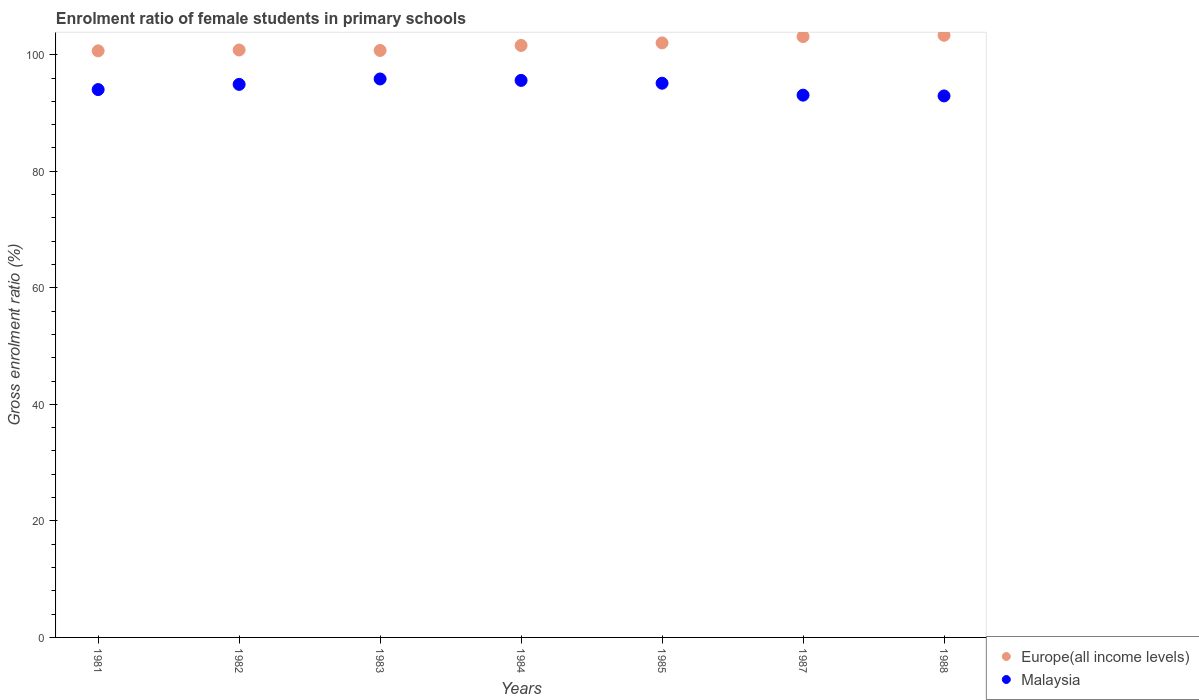Is the number of dotlines equal to the number of legend labels?
Make the answer very short. Yes. What is the enrolment ratio of female students in primary schools in Malaysia in 1982?
Provide a succinct answer. 94.91. Across all years, what is the maximum enrolment ratio of female students in primary schools in Europe(all income levels)?
Provide a short and direct response. 103.33. Across all years, what is the minimum enrolment ratio of female students in primary schools in Malaysia?
Your response must be concise. 92.93. In which year was the enrolment ratio of female students in primary schools in Malaysia maximum?
Your answer should be compact. 1983. What is the total enrolment ratio of female students in primary schools in Malaysia in the graph?
Make the answer very short. 661.44. What is the difference between the enrolment ratio of female students in primary schools in Malaysia in 1985 and that in 1988?
Offer a very short reply. 2.18. What is the difference between the enrolment ratio of female students in primary schools in Europe(all income levels) in 1988 and the enrolment ratio of female students in primary schools in Malaysia in 1987?
Keep it short and to the point. 10.27. What is the average enrolment ratio of female students in primary schools in Malaysia per year?
Your answer should be compact. 94.49. In the year 1988, what is the difference between the enrolment ratio of female students in primary schools in Europe(all income levels) and enrolment ratio of female students in primary schools in Malaysia?
Offer a terse response. 10.41. What is the ratio of the enrolment ratio of female students in primary schools in Malaysia in 1983 to that in 1988?
Your answer should be very brief. 1.03. What is the difference between the highest and the second highest enrolment ratio of female students in primary schools in Malaysia?
Your answer should be compact. 0.25. What is the difference between the highest and the lowest enrolment ratio of female students in primary schools in Malaysia?
Give a very brief answer. 2.91. In how many years, is the enrolment ratio of female students in primary schools in Malaysia greater than the average enrolment ratio of female students in primary schools in Malaysia taken over all years?
Offer a terse response. 4. Is the sum of the enrolment ratio of female students in primary schools in Malaysia in 1985 and 1988 greater than the maximum enrolment ratio of female students in primary schools in Europe(all income levels) across all years?
Your answer should be very brief. Yes. Is the enrolment ratio of female students in primary schools in Malaysia strictly greater than the enrolment ratio of female students in primary schools in Europe(all income levels) over the years?
Your answer should be very brief. No. What is the title of the graph?
Provide a succinct answer. Enrolment ratio of female students in primary schools. Does "Belgium" appear as one of the legend labels in the graph?
Provide a short and direct response. No. What is the label or title of the X-axis?
Provide a succinct answer. Years. What is the label or title of the Y-axis?
Provide a succinct answer. Gross enrolment ratio (%). What is the Gross enrolment ratio (%) of Europe(all income levels) in 1981?
Your response must be concise. 100.66. What is the Gross enrolment ratio (%) in Malaysia in 1981?
Your answer should be very brief. 94.01. What is the Gross enrolment ratio (%) in Europe(all income levels) in 1982?
Ensure brevity in your answer.  100.81. What is the Gross enrolment ratio (%) in Malaysia in 1982?
Your answer should be compact. 94.91. What is the Gross enrolment ratio (%) in Europe(all income levels) in 1983?
Provide a short and direct response. 100.73. What is the Gross enrolment ratio (%) of Malaysia in 1983?
Provide a short and direct response. 95.84. What is the Gross enrolment ratio (%) in Europe(all income levels) in 1984?
Ensure brevity in your answer.  101.59. What is the Gross enrolment ratio (%) in Malaysia in 1984?
Give a very brief answer. 95.59. What is the Gross enrolment ratio (%) in Europe(all income levels) in 1985?
Your answer should be very brief. 102.03. What is the Gross enrolment ratio (%) in Malaysia in 1985?
Provide a succinct answer. 95.1. What is the Gross enrolment ratio (%) in Europe(all income levels) in 1987?
Your answer should be very brief. 103.11. What is the Gross enrolment ratio (%) of Malaysia in 1987?
Keep it short and to the point. 93.06. What is the Gross enrolment ratio (%) in Europe(all income levels) in 1988?
Give a very brief answer. 103.33. What is the Gross enrolment ratio (%) of Malaysia in 1988?
Make the answer very short. 92.93. Across all years, what is the maximum Gross enrolment ratio (%) of Europe(all income levels)?
Your response must be concise. 103.33. Across all years, what is the maximum Gross enrolment ratio (%) of Malaysia?
Offer a very short reply. 95.84. Across all years, what is the minimum Gross enrolment ratio (%) of Europe(all income levels)?
Ensure brevity in your answer.  100.66. Across all years, what is the minimum Gross enrolment ratio (%) in Malaysia?
Your answer should be compact. 92.93. What is the total Gross enrolment ratio (%) of Europe(all income levels) in the graph?
Your response must be concise. 712.26. What is the total Gross enrolment ratio (%) of Malaysia in the graph?
Your response must be concise. 661.44. What is the difference between the Gross enrolment ratio (%) in Europe(all income levels) in 1981 and that in 1982?
Offer a terse response. -0.15. What is the difference between the Gross enrolment ratio (%) of Malaysia in 1981 and that in 1982?
Your answer should be very brief. -0.89. What is the difference between the Gross enrolment ratio (%) of Europe(all income levels) in 1981 and that in 1983?
Offer a terse response. -0.07. What is the difference between the Gross enrolment ratio (%) of Malaysia in 1981 and that in 1983?
Make the answer very short. -1.82. What is the difference between the Gross enrolment ratio (%) of Europe(all income levels) in 1981 and that in 1984?
Ensure brevity in your answer.  -0.93. What is the difference between the Gross enrolment ratio (%) in Malaysia in 1981 and that in 1984?
Provide a succinct answer. -1.58. What is the difference between the Gross enrolment ratio (%) in Europe(all income levels) in 1981 and that in 1985?
Your answer should be compact. -1.37. What is the difference between the Gross enrolment ratio (%) of Malaysia in 1981 and that in 1985?
Your answer should be very brief. -1.09. What is the difference between the Gross enrolment ratio (%) of Europe(all income levels) in 1981 and that in 1987?
Your response must be concise. -2.45. What is the difference between the Gross enrolment ratio (%) of Malaysia in 1981 and that in 1987?
Keep it short and to the point. 0.96. What is the difference between the Gross enrolment ratio (%) in Europe(all income levels) in 1981 and that in 1988?
Offer a very short reply. -2.67. What is the difference between the Gross enrolment ratio (%) of Malaysia in 1981 and that in 1988?
Keep it short and to the point. 1.09. What is the difference between the Gross enrolment ratio (%) in Europe(all income levels) in 1982 and that in 1983?
Give a very brief answer. 0.08. What is the difference between the Gross enrolment ratio (%) in Malaysia in 1982 and that in 1983?
Offer a very short reply. -0.93. What is the difference between the Gross enrolment ratio (%) in Europe(all income levels) in 1982 and that in 1984?
Your answer should be compact. -0.78. What is the difference between the Gross enrolment ratio (%) in Malaysia in 1982 and that in 1984?
Your response must be concise. -0.68. What is the difference between the Gross enrolment ratio (%) in Europe(all income levels) in 1982 and that in 1985?
Offer a terse response. -1.22. What is the difference between the Gross enrolment ratio (%) in Malaysia in 1982 and that in 1985?
Make the answer very short. -0.2. What is the difference between the Gross enrolment ratio (%) of Europe(all income levels) in 1982 and that in 1987?
Your answer should be very brief. -2.31. What is the difference between the Gross enrolment ratio (%) in Malaysia in 1982 and that in 1987?
Provide a succinct answer. 1.85. What is the difference between the Gross enrolment ratio (%) in Europe(all income levels) in 1982 and that in 1988?
Provide a succinct answer. -2.53. What is the difference between the Gross enrolment ratio (%) in Malaysia in 1982 and that in 1988?
Provide a short and direct response. 1.98. What is the difference between the Gross enrolment ratio (%) in Europe(all income levels) in 1983 and that in 1984?
Give a very brief answer. -0.86. What is the difference between the Gross enrolment ratio (%) of Malaysia in 1983 and that in 1984?
Give a very brief answer. 0.25. What is the difference between the Gross enrolment ratio (%) in Europe(all income levels) in 1983 and that in 1985?
Your answer should be compact. -1.3. What is the difference between the Gross enrolment ratio (%) in Malaysia in 1983 and that in 1985?
Keep it short and to the point. 0.73. What is the difference between the Gross enrolment ratio (%) in Europe(all income levels) in 1983 and that in 1987?
Offer a very short reply. -2.38. What is the difference between the Gross enrolment ratio (%) of Malaysia in 1983 and that in 1987?
Your answer should be compact. 2.78. What is the difference between the Gross enrolment ratio (%) of Europe(all income levels) in 1983 and that in 1988?
Ensure brevity in your answer.  -2.6. What is the difference between the Gross enrolment ratio (%) of Malaysia in 1983 and that in 1988?
Provide a short and direct response. 2.91. What is the difference between the Gross enrolment ratio (%) in Europe(all income levels) in 1984 and that in 1985?
Make the answer very short. -0.44. What is the difference between the Gross enrolment ratio (%) in Malaysia in 1984 and that in 1985?
Provide a succinct answer. 0.49. What is the difference between the Gross enrolment ratio (%) of Europe(all income levels) in 1984 and that in 1987?
Your answer should be very brief. -1.52. What is the difference between the Gross enrolment ratio (%) of Malaysia in 1984 and that in 1987?
Provide a short and direct response. 2.53. What is the difference between the Gross enrolment ratio (%) in Europe(all income levels) in 1984 and that in 1988?
Your response must be concise. -1.74. What is the difference between the Gross enrolment ratio (%) in Malaysia in 1984 and that in 1988?
Your response must be concise. 2.66. What is the difference between the Gross enrolment ratio (%) in Europe(all income levels) in 1985 and that in 1987?
Offer a terse response. -1.09. What is the difference between the Gross enrolment ratio (%) of Malaysia in 1985 and that in 1987?
Make the answer very short. 2.05. What is the difference between the Gross enrolment ratio (%) of Europe(all income levels) in 1985 and that in 1988?
Your response must be concise. -1.31. What is the difference between the Gross enrolment ratio (%) of Malaysia in 1985 and that in 1988?
Make the answer very short. 2.18. What is the difference between the Gross enrolment ratio (%) in Europe(all income levels) in 1987 and that in 1988?
Provide a succinct answer. -0.22. What is the difference between the Gross enrolment ratio (%) of Malaysia in 1987 and that in 1988?
Give a very brief answer. 0.13. What is the difference between the Gross enrolment ratio (%) of Europe(all income levels) in 1981 and the Gross enrolment ratio (%) of Malaysia in 1982?
Ensure brevity in your answer.  5.75. What is the difference between the Gross enrolment ratio (%) in Europe(all income levels) in 1981 and the Gross enrolment ratio (%) in Malaysia in 1983?
Provide a short and direct response. 4.82. What is the difference between the Gross enrolment ratio (%) of Europe(all income levels) in 1981 and the Gross enrolment ratio (%) of Malaysia in 1984?
Offer a very short reply. 5.07. What is the difference between the Gross enrolment ratio (%) of Europe(all income levels) in 1981 and the Gross enrolment ratio (%) of Malaysia in 1985?
Ensure brevity in your answer.  5.56. What is the difference between the Gross enrolment ratio (%) in Europe(all income levels) in 1981 and the Gross enrolment ratio (%) in Malaysia in 1987?
Offer a very short reply. 7.6. What is the difference between the Gross enrolment ratio (%) in Europe(all income levels) in 1981 and the Gross enrolment ratio (%) in Malaysia in 1988?
Ensure brevity in your answer.  7.73. What is the difference between the Gross enrolment ratio (%) of Europe(all income levels) in 1982 and the Gross enrolment ratio (%) of Malaysia in 1983?
Provide a succinct answer. 4.97. What is the difference between the Gross enrolment ratio (%) of Europe(all income levels) in 1982 and the Gross enrolment ratio (%) of Malaysia in 1984?
Give a very brief answer. 5.22. What is the difference between the Gross enrolment ratio (%) of Europe(all income levels) in 1982 and the Gross enrolment ratio (%) of Malaysia in 1985?
Offer a very short reply. 5.7. What is the difference between the Gross enrolment ratio (%) of Europe(all income levels) in 1982 and the Gross enrolment ratio (%) of Malaysia in 1987?
Your answer should be compact. 7.75. What is the difference between the Gross enrolment ratio (%) of Europe(all income levels) in 1982 and the Gross enrolment ratio (%) of Malaysia in 1988?
Give a very brief answer. 7.88. What is the difference between the Gross enrolment ratio (%) of Europe(all income levels) in 1983 and the Gross enrolment ratio (%) of Malaysia in 1984?
Keep it short and to the point. 5.14. What is the difference between the Gross enrolment ratio (%) in Europe(all income levels) in 1983 and the Gross enrolment ratio (%) in Malaysia in 1985?
Keep it short and to the point. 5.63. What is the difference between the Gross enrolment ratio (%) of Europe(all income levels) in 1983 and the Gross enrolment ratio (%) of Malaysia in 1987?
Give a very brief answer. 7.67. What is the difference between the Gross enrolment ratio (%) of Europe(all income levels) in 1983 and the Gross enrolment ratio (%) of Malaysia in 1988?
Offer a very short reply. 7.8. What is the difference between the Gross enrolment ratio (%) of Europe(all income levels) in 1984 and the Gross enrolment ratio (%) of Malaysia in 1985?
Your answer should be compact. 6.48. What is the difference between the Gross enrolment ratio (%) of Europe(all income levels) in 1984 and the Gross enrolment ratio (%) of Malaysia in 1987?
Provide a succinct answer. 8.53. What is the difference between the Gross enrolment ratio (%) of Europe(all income levels) in 1984 and the Gross enrolment ratio (%) of Malaysia in 1988?
Offer a terse response. 8.66. What is the difference between the Gross enrolment ratio (%) of Europe(all income levels) in 1985 and the Gross enrolment ratio (%) of Malaysia in 1987?
Make the answer very short. 8.97. What is the difference between the Gross enrolment ratio (%) of Europe(all income levels) in 1985 and the Gross enrolment ratio (%) of Malaysia in 1988?
Make the answer very short. 9.1. What is the difference between the Gross enrolment ratio (%) in Europe(all income levels) in 1987 and the Gross enrolment ratio (%) in Malaysia in 1988?
Your response must be concise. 10.19. What is the average Gross enrolment ratio (%) in Europe(all income levels) per year?
Provide a succinct answer. 101.75. What is the average Gross enrolment ratio (%) in Malaysia per year?
Make the answer very short. 94.49. In the year 1981, what is the difference between the Gross enrolment ratio (%) in Europe(all income levels) and Gross enrolment ratio (%) in Malaysia?
Your answer should be compact. 6.65. In the year 1982, what is the difference between the Gross enrolment ratio (%) in Europe(all income levels) and Gross enrolment ratio (%) in Malaysia?
Offer a very short reply. 5.9. In the year 1983, what is the difference between the Gross enrolment ratio (%) of Europe(all income levels) and Gross enrolment ratio (%) of Malaysia?
Your response must be concise. 4.89. In the year 1984, what is the difference between the Gross enrolment ratio (%) of Europe(all income levels) and Gross enrolment ratio (%) of Malaysia?
Make the answer very short. 6. In the year 1985, what is the difference between the Gross enrolment ratio (%) in Europe(all income levels) and Gross enrolment ratio (%) in Malaysia?
Make the answer very short. 6.92. In the year 1987, what is the difference between the Gross enrolment ratio (%) of Europe(all income levels) and Gross enrolment ratio (%) of Malaysia?
Provide a short and direct response. 10.05. In the year 1988, what is the difference between the Gross enrolment ratio (%) in Europe(all income levels) and Gross enrolment ratio (%) in Malaysia?
Make the answer very short. 10.41. What is the ratio of the Gross enrolment ratio (%) of Malaysia in 1981 to that in 1982?
Offer a terse response. 0.99. What is the ratio of the Gross enrolment ratio (%) in Europe(all income levels) in 1981 to that in 1983?
Your response must be concise. 1. What is the ratio of the Gross enrolment ratio (%) in Europe(all income levels) in 1981 to that in 1984?
Offer a terse response. 0.99. What is the ratio of the Gross enrolment ratio (%) of Malaysia in 1981 to that in 1984?
Offer a terse response. 0.98. What is the ratio of the Gross enrolment ratio (%) of Europe(all income levels) in 1981 to that in 1985?
Provide a succinct answer. 0.99. What is the ratio of the Gross enrolment ratio (%) of Europe(all income levels) in 1981 to that in 1987?
Make the answer very short. 0.98. What is the ratio of the Gross enrolment ratio (%) of Malaysia in 1981 to that in 1987?
Your response must be concise. 1.01. What is the ratio of the Gross enrolment ratio (%) of Europe(all income levels) in 1981 to that in 1988?
Give a very brief answer. 0.97. What is the ratio of the Gross enrolment ratio (%) in Malaysia in 1981 to that in 1988?
Provide a succinct answer. 1.01. What is the ratio of the Gross enrolment ratio (%) of Malaysia in 1982 to that in 1983?
Your response must be concise. 0.99. What is the ratio of the Gross enrolment ratio (%) in Europe(all income levels) in 1982 to that in 1984?
Provide a short and direct response. 0.99. What is the ratio of the Gross enrolment ratio (%) in Europe(all income levels) in 1982 to that in 1985?
Your answer should be compact. 0.99. What is the ratio of the Gross enrolment ratio (%) of Europe(all income levels) in 1982 to that in 1987?
Give a very brief answer. 0.98. What is the ratio of the Gross enrolment ratio (%) of Malaysia in 1982 to that in 1987?
Ensure brevity in your answer.  1.02. What is the ratio of the Gross enrolment ratio (%) in Europe(all income levels) in 1982 to that in 1988?
Provide a short and direct response. 0.98. What is the ratio of the Gross enrolment ratio (%) in Malaysia in 1982 to that in 1988?
Your response must be concise. 1.02. What is the ratio of the Gross enrolment ratio (%) in Europe(all income levels) in 1983 to that in 1985?
Give a very brief answer. 0.99. What is the ratio of the Gross enrolment ratio (%) in Malaysia in 1983 to that in 1985?
Offer a terse response. 1.01. What is the ratio of the Gross enrolment ratio (%) in Europe(all income levels) in 1983 to that in 1987?
Make the answer very short. 0.98. What is the ratio of the Gross enrolment ratio (%) of Malaysia in 1983 to that in 1987?
Your answer should be very brief. 1.03. What is the ratio of the Gross enrolment ratio (%) in Europe(all income levels) in 1983 to that in 1988?
Give a very brief answer. 0.97. What is the ratio of the Gross enrolment ratio (%) in Malaysia in 1983 to that in 1988?
Your response must be concise. 1.03. What is the ratio of the Gross enrolment ratio (%) of Europe(all income levels) in 1984 to that in 1987?
Your answer should be compact. 0.99. What is the ratio of the Gross enrolment ratio (%) in Malaysia in 1984 to that in 1987?
Offer a very short reply. 1.03. What is the ratio of the Gross enrolment ratio (%) in Europe(all income levels) in 1984 to that in 1988?
Provide a short and direct response. 0.98. What is the ratio of the Gross enrolment ratio (%) in Malaysia in 1984 to that in 1988?
Offer a very short reply. 1.03. What is the ratio of the Gross enrolment ratio (%) in Europe(all income levels) in 1985 to that in 1988?
Make the answer very short. 0.99. What is the ratio of the Gross enrolment ratio (%) in Malaysia in 1985 to that in 1988?
Give a very brief answer. 1.02. What is the difference between the highest and the second highest Gross enrolment ratio (%) of Europe(all income levels)?
Give a very brief answer. 0.22. What is the difference between the highest and the second highest Gross enrolment ratio (%) in Malaysia?
Offer a terse response. 0.25. What is the difference between the highest and the lowest Gross enrolment ratio (%) in Europe(all income levels)?
Offer a very short reply. 2.67. What is the difference between the highest and the lowest Gross enrolment ratio (%) of Malaysia?
Ensure brevity in your answer.  2.91. 